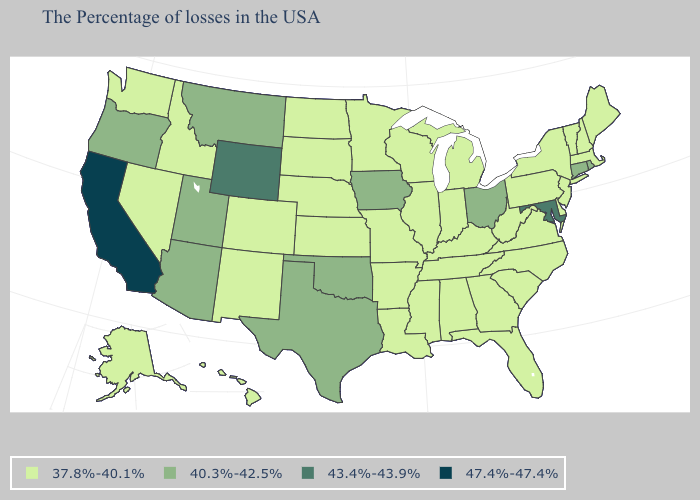Does California have the highest value in the West?
Be succinct. Yes. Does Maryland have the lowest value in the USA?
Write a very short answer. No. Among the states that border Massachusetts , which have the highest value?
Write a very short answer. Rhode Island, Connecticut. Name the states that have a value in the range 43.4%-43.9%?
Write a very short answer. Maryland, Wyoming. Name the states that have a value in the range 47.4%-47.4%?
Concise answer only. California. Does Idaho have a lower value than Oregon?
Short answer required. Yes. Name the states that have a value in the range 40.3%-42.5%?
Short answer required. Rhode Island, Connecticut, Ohio, Iowa, Oklahoma, Texas, Utah, Montana, Arizona, Oregon. What is the lowest value in the USA?
Short answer required. 37.8%-40.1%. What is the value of Virginia?
Answer briefly. 37.8%-40.1%. Name the states that have a value in the range 37.8%-40.1%?
Write a very short answer. Maine, Massachusetts, New Hampshire, Vermont, New York, New Jersey, Delaware, Pennsylvania, Virginia, North Carolina, South Carolina, West Virginia, Florida, Georgia, Michigan, Kentucky, Indiana, Alabama, Tennessee, Wisconsin, Illinois, Mississippi, Louisiana, Missouri, Arkansas, Minnesota, Kansas, Nebraska, South Dakota, North Dakota, Colorado, New Mexico, Idaho, Nevada, Washington, Alaska, Hawaii. What is the highest value in the South ?
Concise answer only. 43.4%-43.9%. What is the value of Texas?
Write a very short answer. 40.3%-42.5%. Is the legend a continuous bar?
Concise answer only. No. Name the states that have a value in the range 43.4%-43.9%?
Write a very short answer. Maryland, Wyoming. Does the map have missing data?
Write a very short answer. No. 